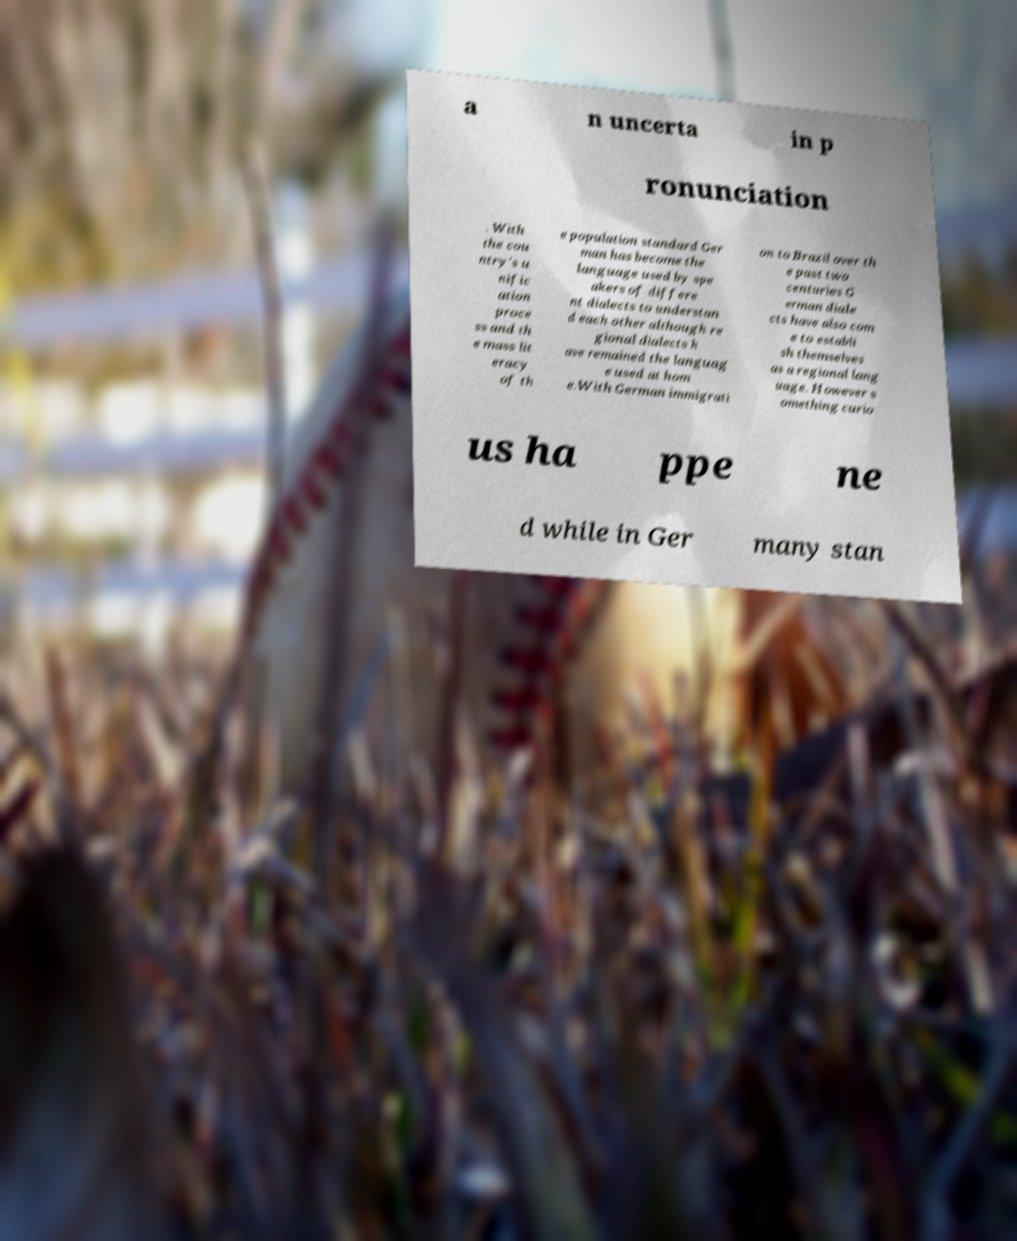There's text embedded in this image that I need extracted. Can you transcribe it verbatim? a n uncerta in p ronunciation . With the cou ntry's u nific ation proce ss and th e mass lit eracy of th e population standard Ger man has become the language used by spe akers of differe nt dialects to understan d each other although re gional dialects h ave remained the languag e used at hom e.With German immigrati on to Brazil over th e past two centuries G erman diale cts have also com e to establi sh themselves as a regional lang uage. However s omething curio us ha ppe ne d while in Ger many stan 